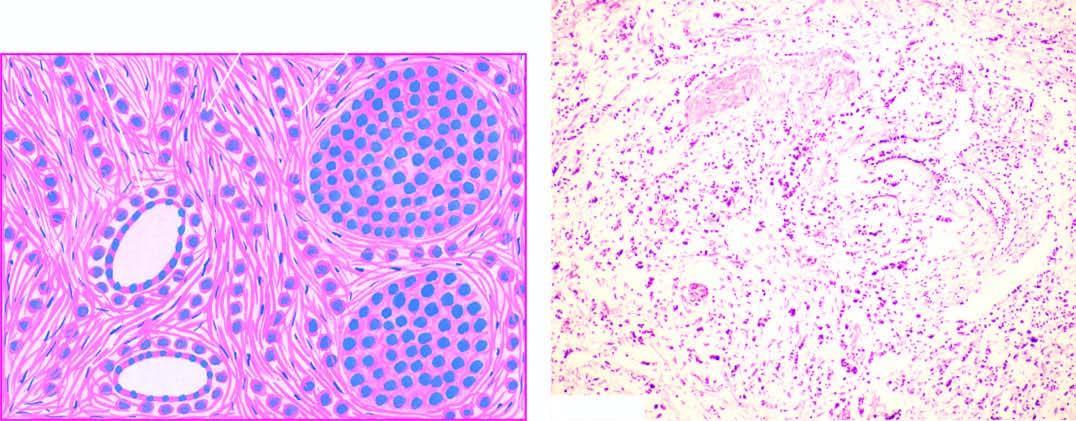how much cell are characteristic histologic features?
Answer the question using a single word or phrase. One 